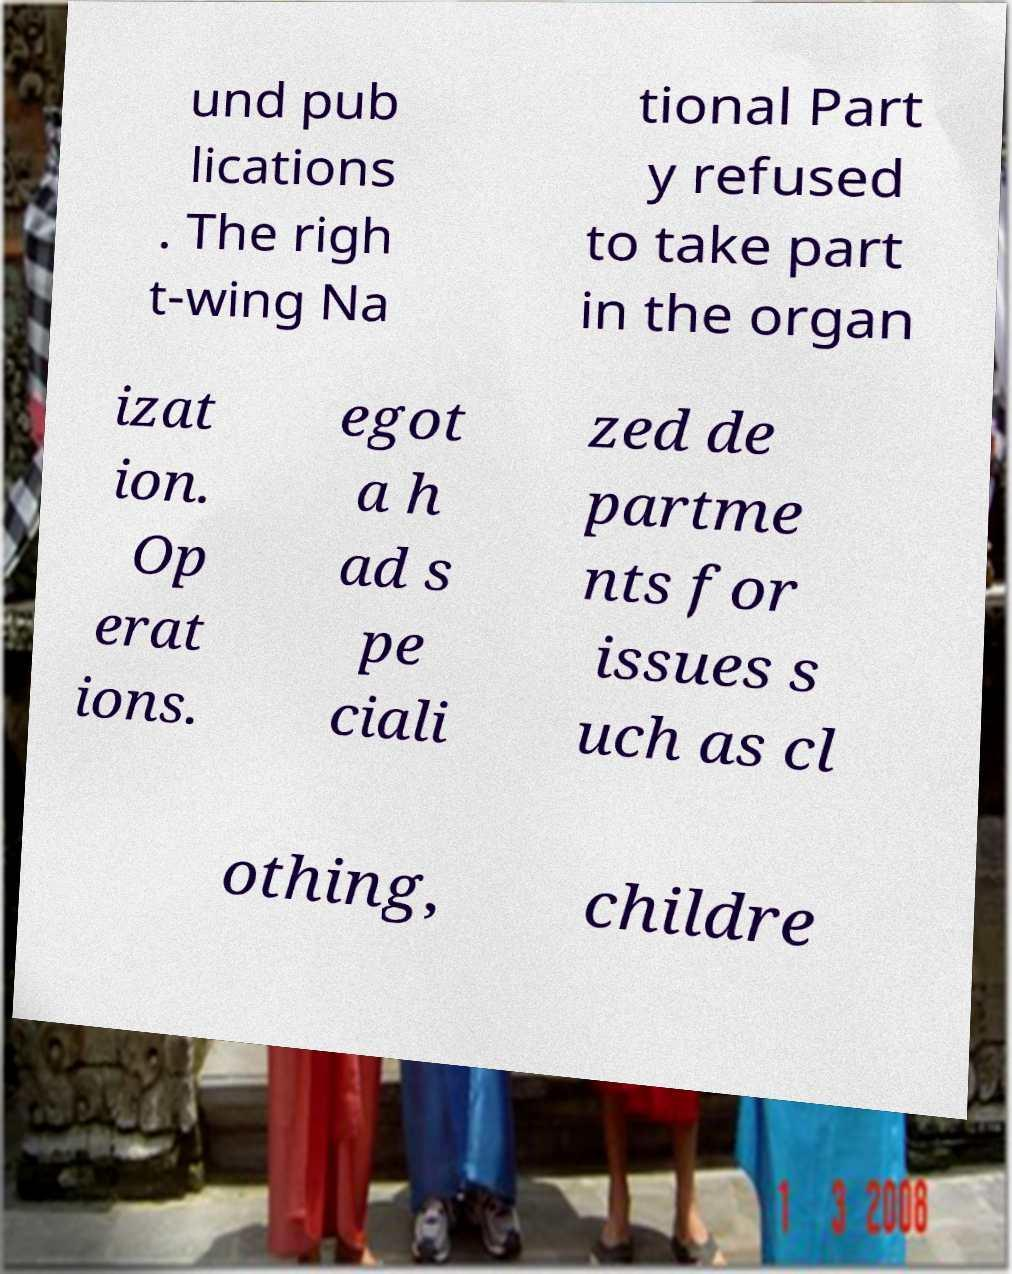Can you accurately transcribe the text from the provided image for me? und pub lications . The righ t-wing Na tional Part y refused to take part in the organ izat ion. Op erat ions. egot a h ad s pe ciali zed de partme nts for issues s uch as cl othing, childre 